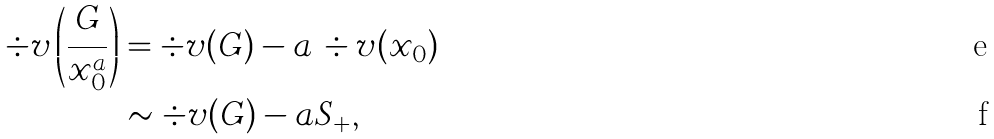Convert formula to latex. <formula><loc_0><loc_0><loc_500><loc_500>\div v \left ( \frac { G } { x _ { 0 } ^ { a } } \right ) & = \div v ( G ) - a \, \div v ( x _ { 0 } ) \\ & \sim \div v ( G ) - a S _ { + } ,</formula> 